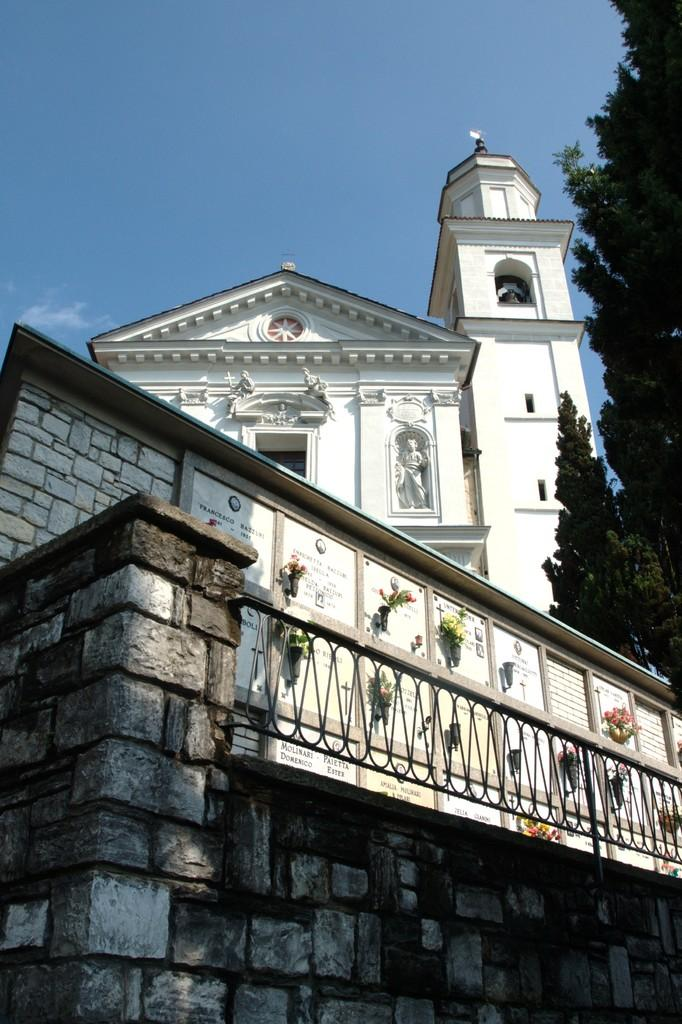What is the main structure in the middle of the image? There is a building in the middle of the image. What type of vegetation can be seen on the right side of the image? There are trees on the right side of the image. What is located at the bottom of the image? There is a wall at the bottom of the image. What is attached to the wall? There is a fence on the wall. What is visible at the top of the image? The sky is visible at the top of the image. What scent can be detected from the story being told in the image? There is no story being told in the image, and therefore no scent can be detected. 